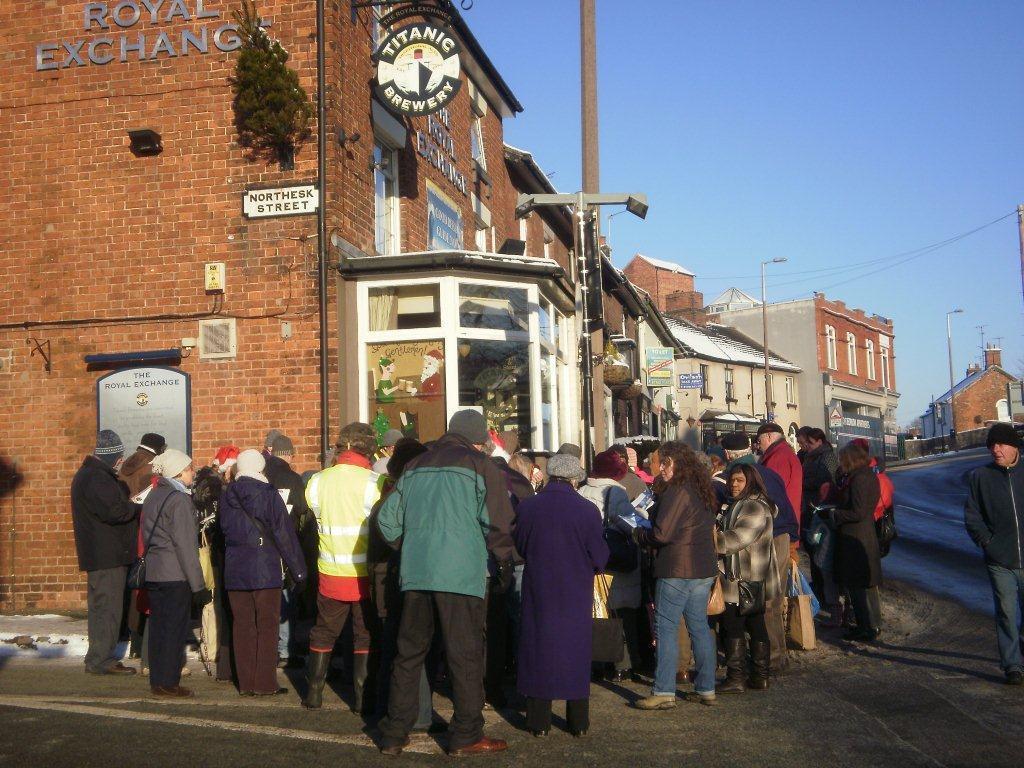Could you give a brief overview of what you see in this image? In this image I can see the ground, number of persons wearing jackets are standing on the ground, the road, some snow on the road and few buildings which are brown, cream and white in color. I can see a plant to the building, few boards, few poles, few antennas on the building and in the background I can see the sky. 